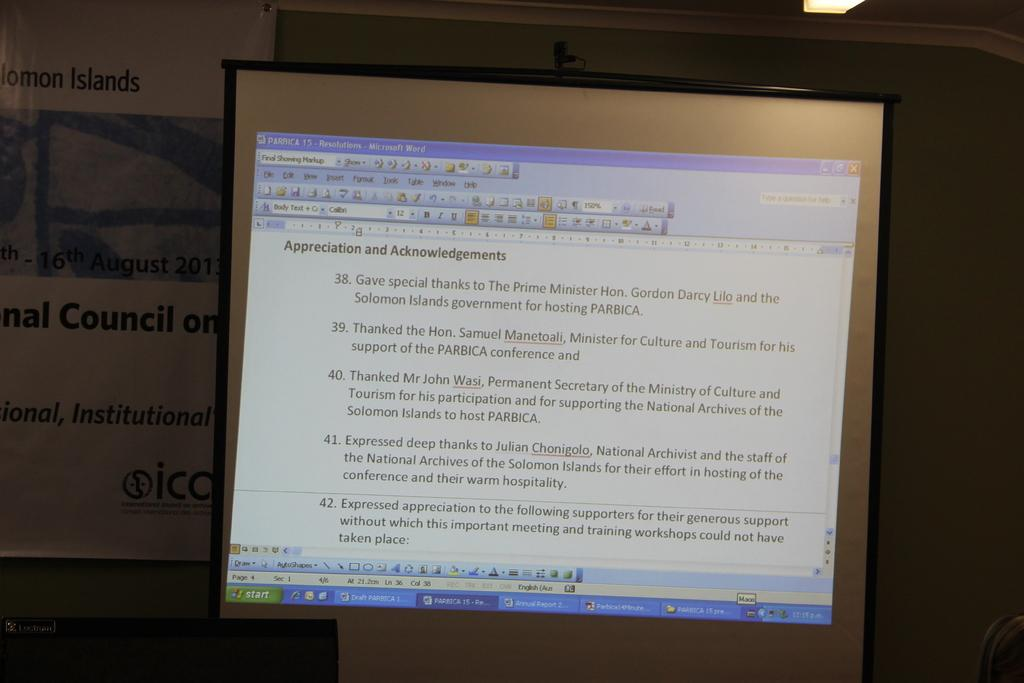<image>
Give a short and clear explanation of the subsequent image. A monitor shows a document about Appreciation and Acknowledgements. 